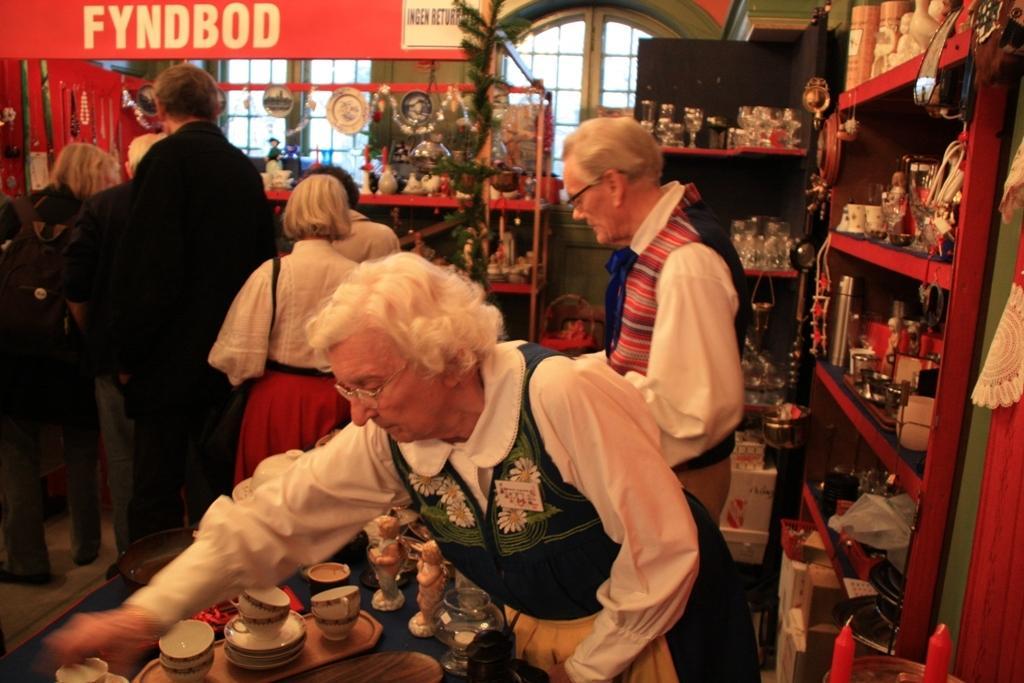Could you give a brief overview of what you see in this image? There are people. We can see cups, saucers, dolls and few objects on the table. On the right side of the image we can see objects in racks, curtain and candles. We can see boxes. In the background we can see glasses and objects in racks, wall and windows. We can see board. 